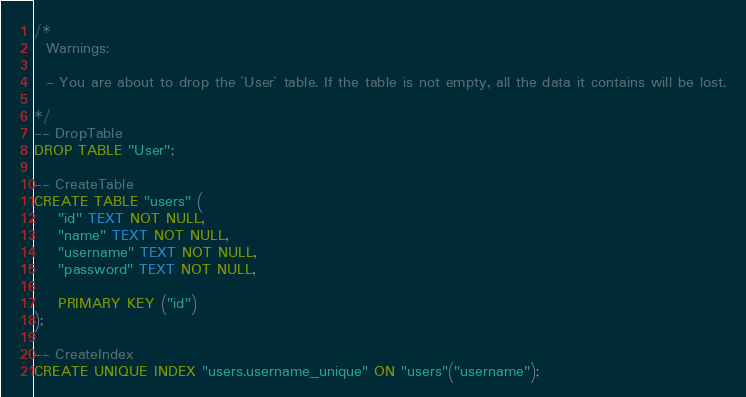Convert code to text. <code><loc_0><loc_0><loc_500><loc_500><_SQL_>/*
  Warnings:

  - You are about to drop the `User` table. If the table is not empty, all the data it contains will be lost.

*/
-- DropTable
DROP TABLE "User";

-- CreateTable
CREATE TABLE "users" (
    "id" TEXT NOT NULL,
    "name" TEXT NOT NULL,
    "username" TEXT NOT NULL,
    "password" TEXT NOT NULL,

    PRIMARY KEY ("id")
);

-- CreateIndex
CREATE UNIQUE INDEX "users.username_unique" ON "users"("username");
</code> 